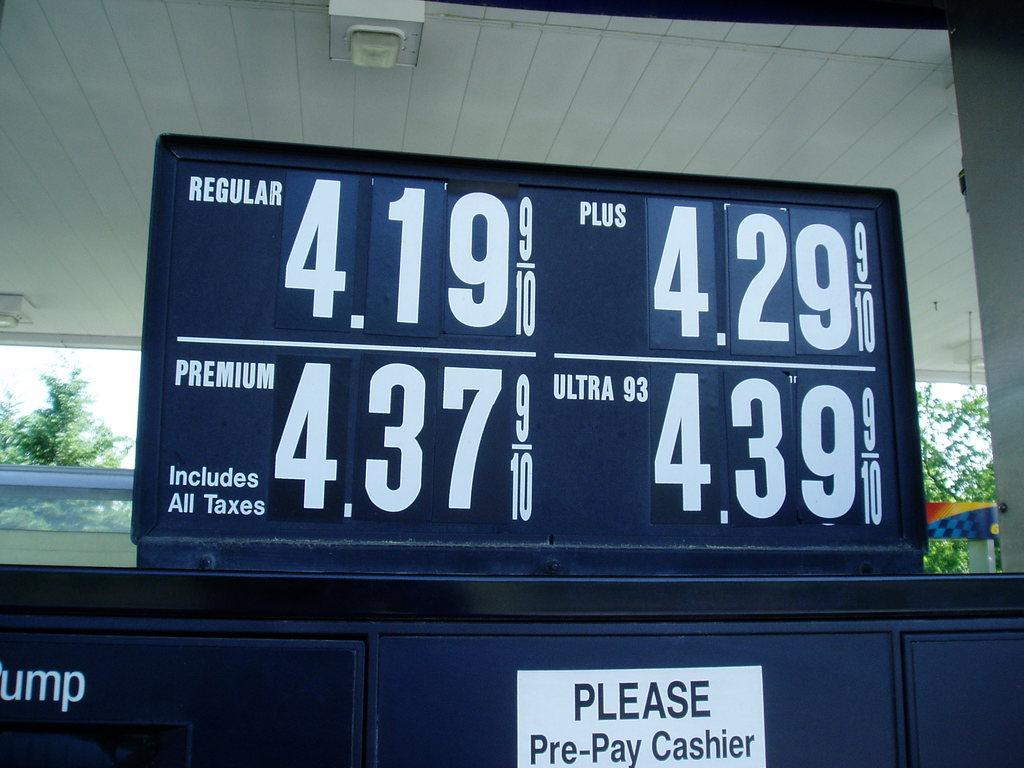Provide a one-sentence caption for the provided image. gas prices above a gas pump that are 4.19. 